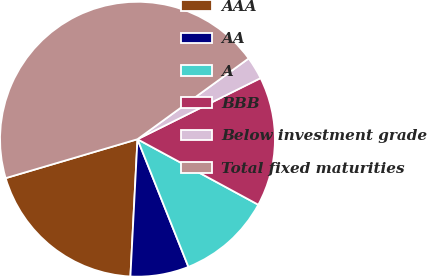Convert chart to OTSL. <chart><loc_0><loc_0><loc_500><loc_500><pie_chart><fcel>AAA<fcel>AA<fcel>A<fcel>BBB<fcel>Below investment grade<fcel>Total fixed maturities<nl><fcel>19.61%<fcel>6.86%<fcel>11.05%<fcel>15.24%<fcel>2.67%<fcel>44.56%<nl></chart> 